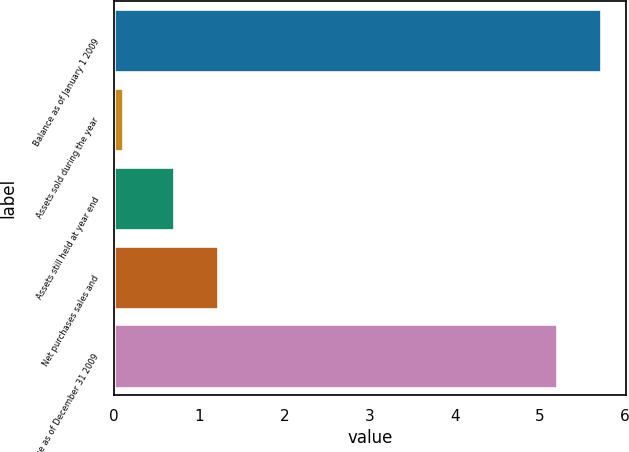<chart> <loc_0><loc_0><loc_500><loc_500><bar_chart><fcel>Balance as of January 1 2009<fcel>Assets sold during the year<fcel>Assets still held at year end<fcel>Net purchases sales and<fcel>Balance as of December 31 2009<nl><fcel>5.72<fcel>0.1<fcel>0.7<fcel>1.22<fcel>5.2<nl></chart> 